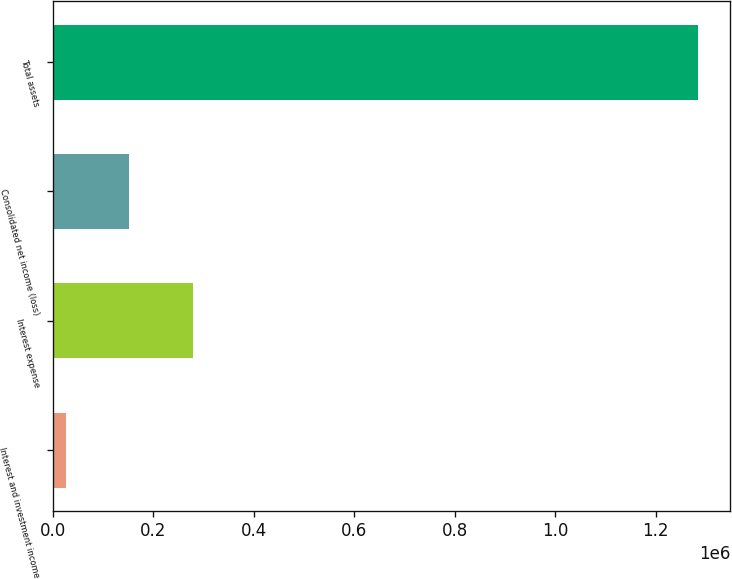Convert chart. <chart><loc_0><loc_0><loc_500><loc_500><bar_chart><fcel>Interest and investment income<fcel>Interest expense<fcel>Consolidated net income (loss)<fcel>Total assets<nl><fcel>27385<fcel>278671<fcel>153028<fcel>1.28382e+06<nl></chart> 